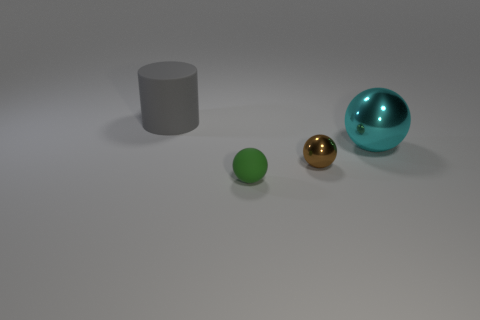There is a big cyan thing; how many green rubber spheres are in front of it?
Keep it short and to the point. 1. Is there a gray thing of the same size as the brown sphere?
Provide a succinct answer. No. What is the color of the other metal object that is the same shape as the tiny shiny thing?
Give a very brief answer. Cyan. Does the shiny thing that is in front of the big cyan metal thing have the same size as the thing left of the small matte object?
Provide a short and direct response. No. Is there another small thing of the same shape as the gray object?
Offer a terse response. No. Is the number of big cylinders in front of the tiny matte object the same as the number of balls?
Give a very brief answer. No. Is the size of the gray thing the same as the matte object that is to the right of the big matte cylinder?
Make the answer very short. No. How many big gray objects have the same material as the big cyan sphere?
Your answer should be compact. 0. Is the size of the brown thing the same as the green rubber object?
Give a very brief answer. Yes. Are there any other things of the same color as the rubber sphere?
Make the answer very short. No. 